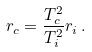Convert formula to latex. <formula><loc_0><loc_0><loc_500><loc_500>r _ { c } = \frac { T _ { c } ^ { 2 } } { T _ { i } ^ { 2 } } r _ { i } \, .</formula> 